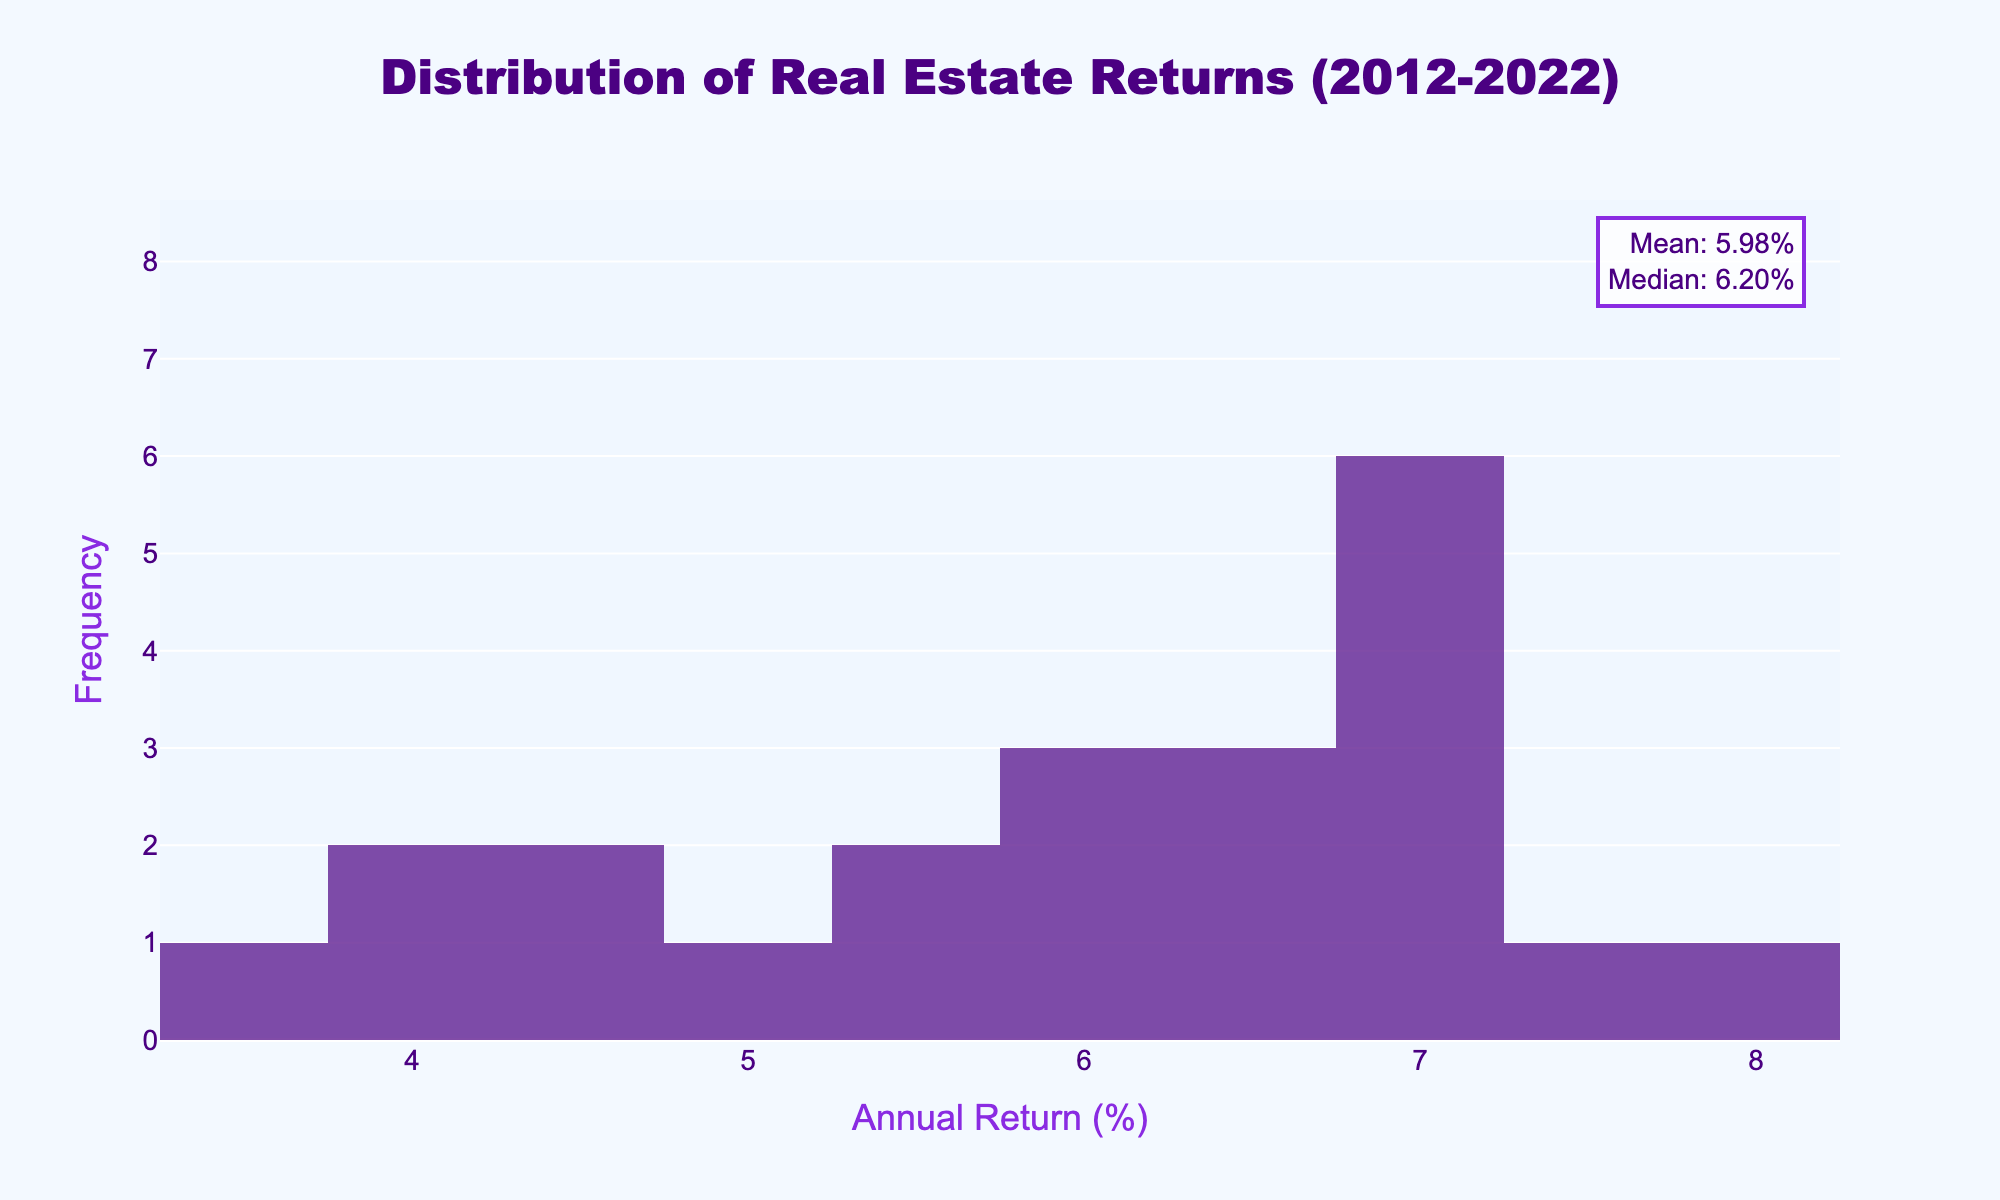What is the title of the plot? The title of the plot is usually found at the top center of the figure. It provides a concise description of what the plot is about, which in this case refers to the data distribution over a specific time period.
Answer: Distribution of Real Estate Returns (2012-2022) What is the x-axis title? The x-axis title is located below the horizontal axis of the plot. It describes what data the x-axis represents, helping the viewer understand the variable being measured horizontally.
Answer: Annual Return (%) What color is the histogram's bars? By observing the bars, you can see their color, which helps differentiate various parts of the plot.
Answer: Indigo What key statistical values are mentioned in the annotations? Annotations in the plot often provide additional information. In this figure, look for text outside the main plot area, usually in a corner.
Answer: Mean and Median What are the mean and median values annotated on the plot? Look at the upper annotation to find the specific mean and median values. These values summarize the central tendency of the data distribution.
Answer: Mean: 5.84%; Median: 6.10% How many bins are in the histogram? The histogram shows data grouped into bins along the x-axis. Count the number of vertical bars to determine the number of bins.
Answer: 10 What is the range of annual returns shown on the x-axis? Observing the x-axis, identify the lowest and highest values that mark the boundaries of the bins, which represent the range of annual returns.
Answer: 3.5% to 8.2% What can you infer about the distribution of returns based on the histogram and violin plot? By analyzing both the histogram and violin plot together, you can understand the data's distribution shape. Note the frequency distribution in the histogram and the spread and central values in the violin plot.
Answer: The returns are relatively evenly spread from 3.5% to 8.2%, with a slight peak around 6%-7% Do the majority of returns fall above or below the mean? Comparing the heights of the histogram bars above and below the mean value helps estimate where most data points lie.
Answer: Below Which statistic (mean or median) is higher and what does this indicate about the distribution? Compare the mean and median values provided in the annotation. This comparison can indicate the skewness of the distribution: whether it's skewed left or right.
Answer: Median; It suggests a slightly left-skewed distribution, as the median is higher than the mean 